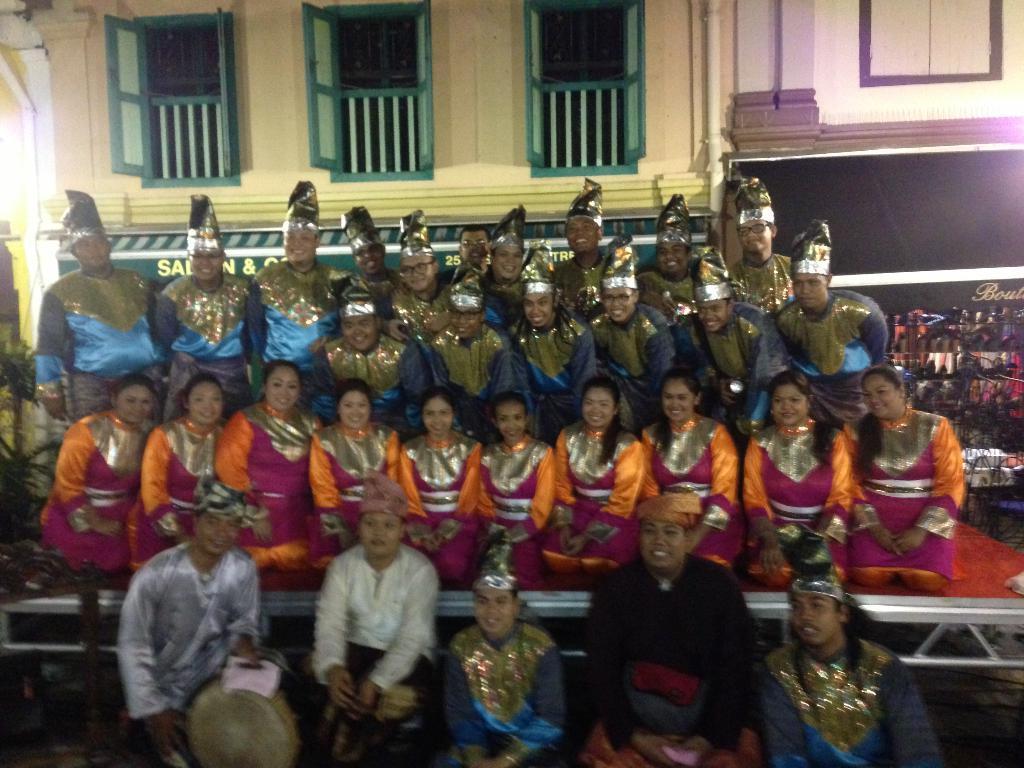Could you give a brief overview of what you see in this image? In this image, we can see people wearing costumes and in the background, there is a building and we can see windows to it and there is a board on the right. 